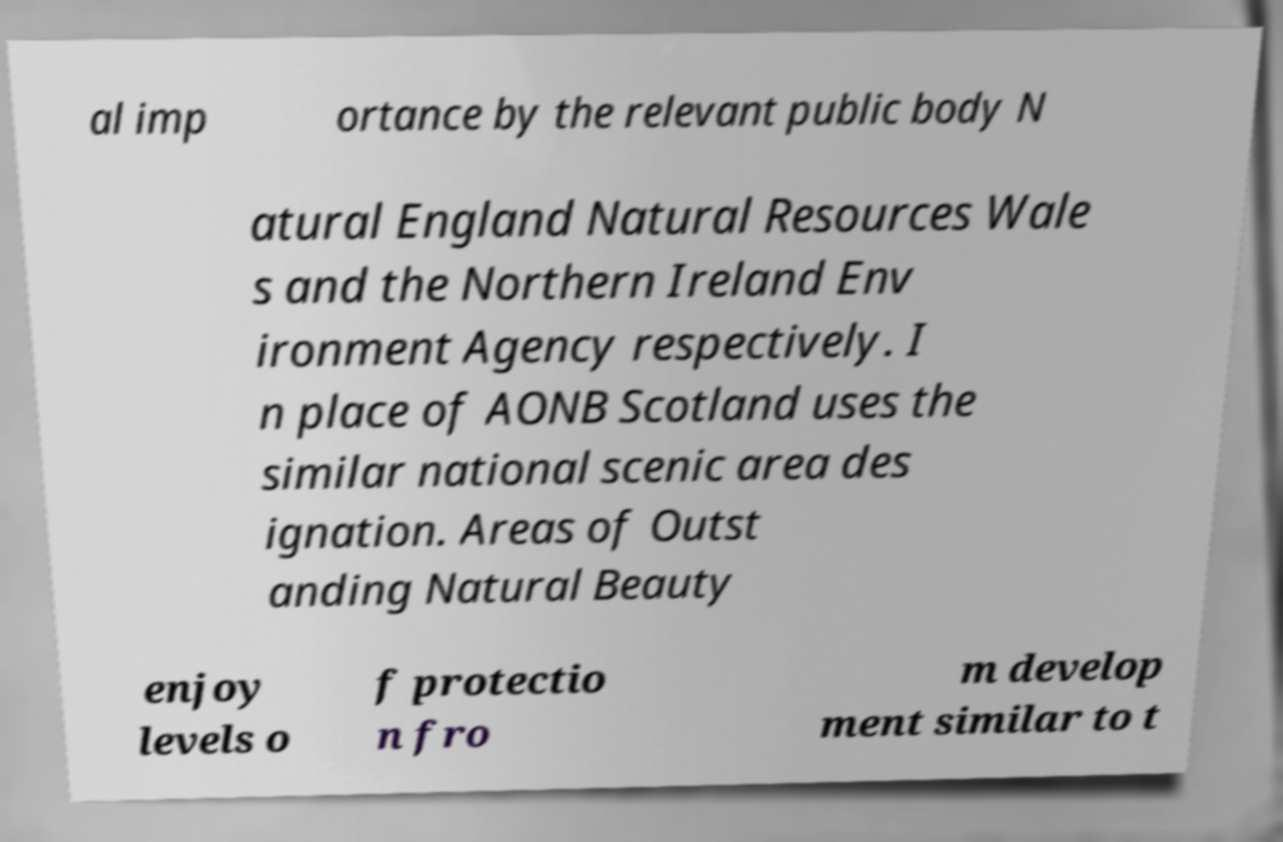Please identify and transcribe the text found in this image. al imp ortance by the relevant public body N atural England Natural Resources Wale s and the Northern Ireland Env ironment Agency respectively. I n place of AONB Scotland uses the similar national scenic area des ignation. Areas of Outst anding Natural Beauty enjoy levels o f protectio n fro m develop ment similar to t 